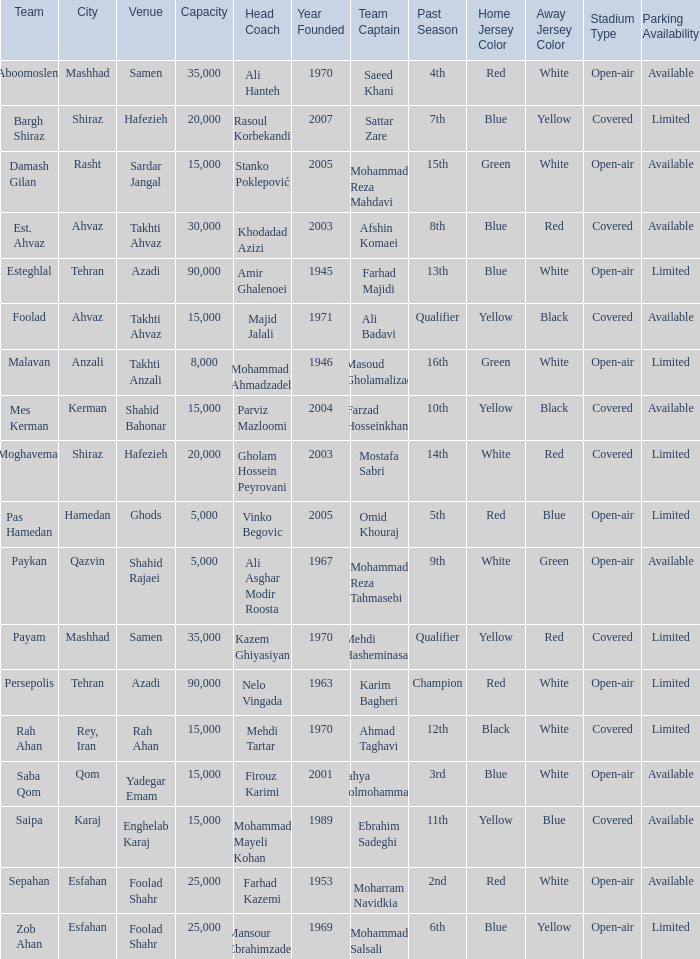What Venue has a Past Season of 2nd? Foolad Shahr. 